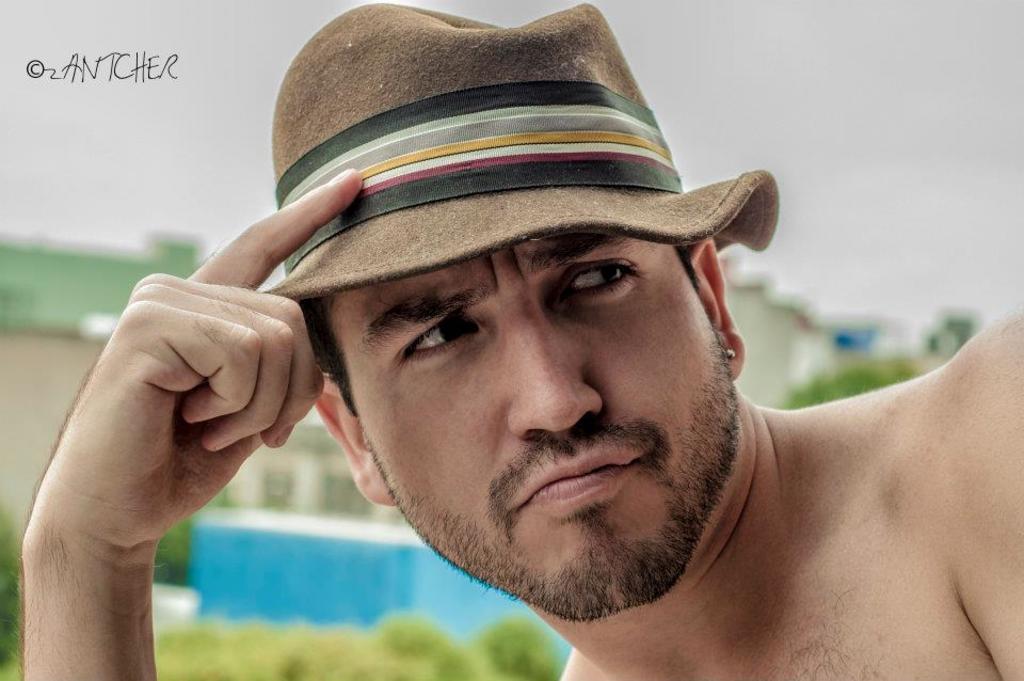Can you describe this image briefly? In this picture I can see a man in front who is wearing a hat which is of brown, black, grey, white, yellow and red color. On the top left corner of this picture I can see the watermark and I see that it is blurred in the background. 